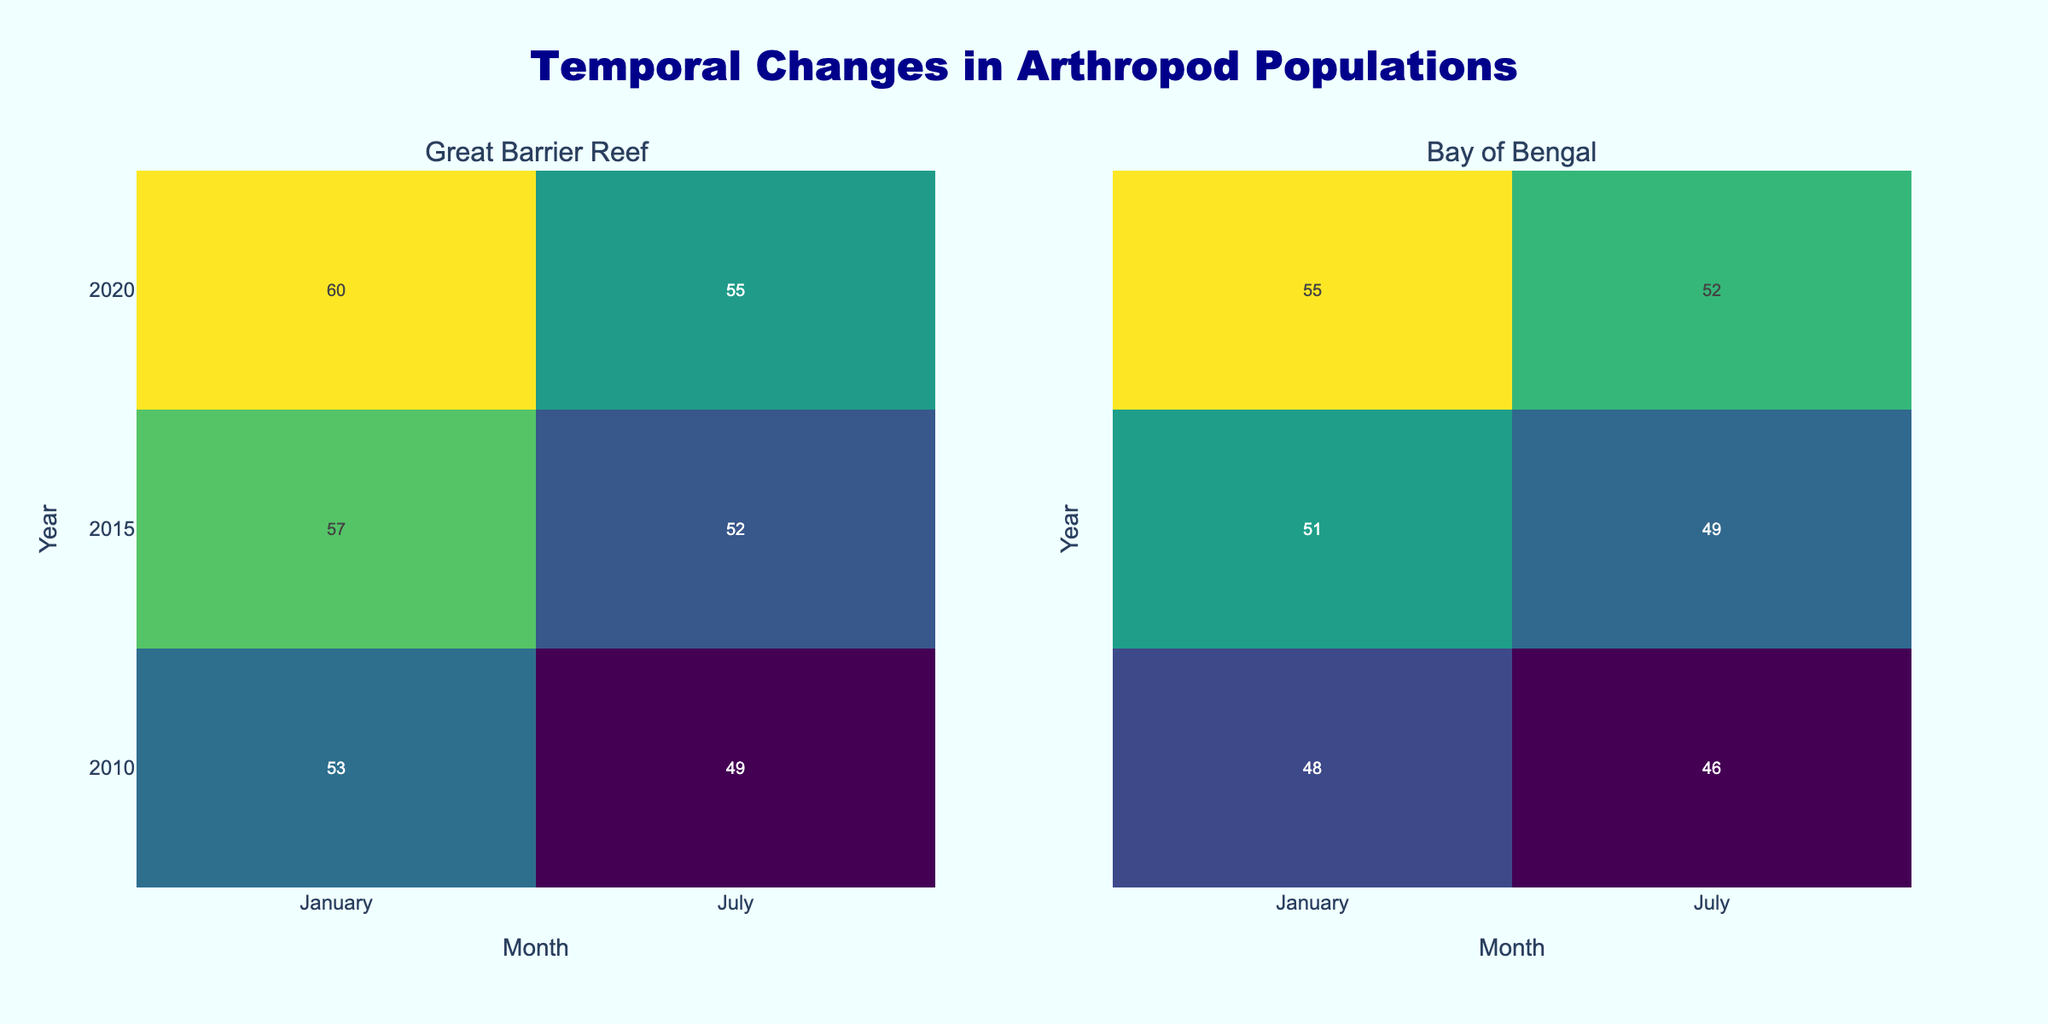What is the title of the figure? The title is located at the top center of the figure and reads, "Temporal Changes in Arthropod Populations."
Answer: Temporal Changes in Arthropod Populations In which month and year at the Great Barrier Reef was the highest arthropod count recorded for Cerataspis platarus? Look at the heatmap under "Great Barrier Reef" for Cerataspis platarus. The highest value is 54, which occurs in January 2020.
Answer: January 2020 Compare the arthropod count of Sergestes similis in January 2010 across both locations. Look at the heatmaps for Sergestes similis in January 2010 for both locations. The counts are 53 for the Great Barrier Reef and 48 for the Bay of Bengal.
Answer: 53 (Great Barrier Reef), 48 (Bay of Bengal) What is the average arthropod count for Cerataspis platarus in July across all years at the Bay of Bengal? Observe the counts for Cerataspis platarus in July 2010 (39), 2015 (43), and 2020 (48) at the Bay of Bengal. The average is (39+43+48)/3 = 43.33.
Answer: 43.33 How does the arthropod count of Sergestes similis in July 2020 at the Great Barrier Reef compare to its count in January 2020? Check the heatmap for Sergestes similis at the Great Barrier Reef in July 2020 (55) and January 2020 (60). Compare these counts: 55 is less than 60.
Answer: Less in July 2020 Which arthropod species had the greatest increase in count from January 2010 to January 2020 at the Bay of Bengal? Calculate the difference for both species: Cerataspis platarus (51-44=7); Sergestes similis (55-48=7); both increases are equal.
Answer: Both species equally What is the overall trend in water temperature from 2010 to 2020 in both locations? Not directly visible on the heatmap, but by referring indirectly, temperatures seem to increase over the years (increasing arthropod counts suggest hotter conditions).
Answer: Increasing In July 2015, which arthropod species had a higher count at the Great Barrier Reef, and what was the count? Look at the July 2015 heatmap for the Great Barrier Reef. Compare counts: Cerataspis platarus (45) and Sergestes similis (52).
Answer: Sergestes similis, 52 What visual element indicates the arthropod count in the heatmap? The color intensity on the heatmap represents the arthropod count, with more intense colors indicating higher counts.
Answer: Color intensity 